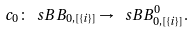Convert formula to latex. <formula><loc_0><loc_0><loc_500><loc_500>c _ { 0 } \colon \ s B B _ { 0 , [ \{ i \} ] } \to \ s B B _ { 0 , [ \{ i \} ] } ^ { 0 } .</formula> 